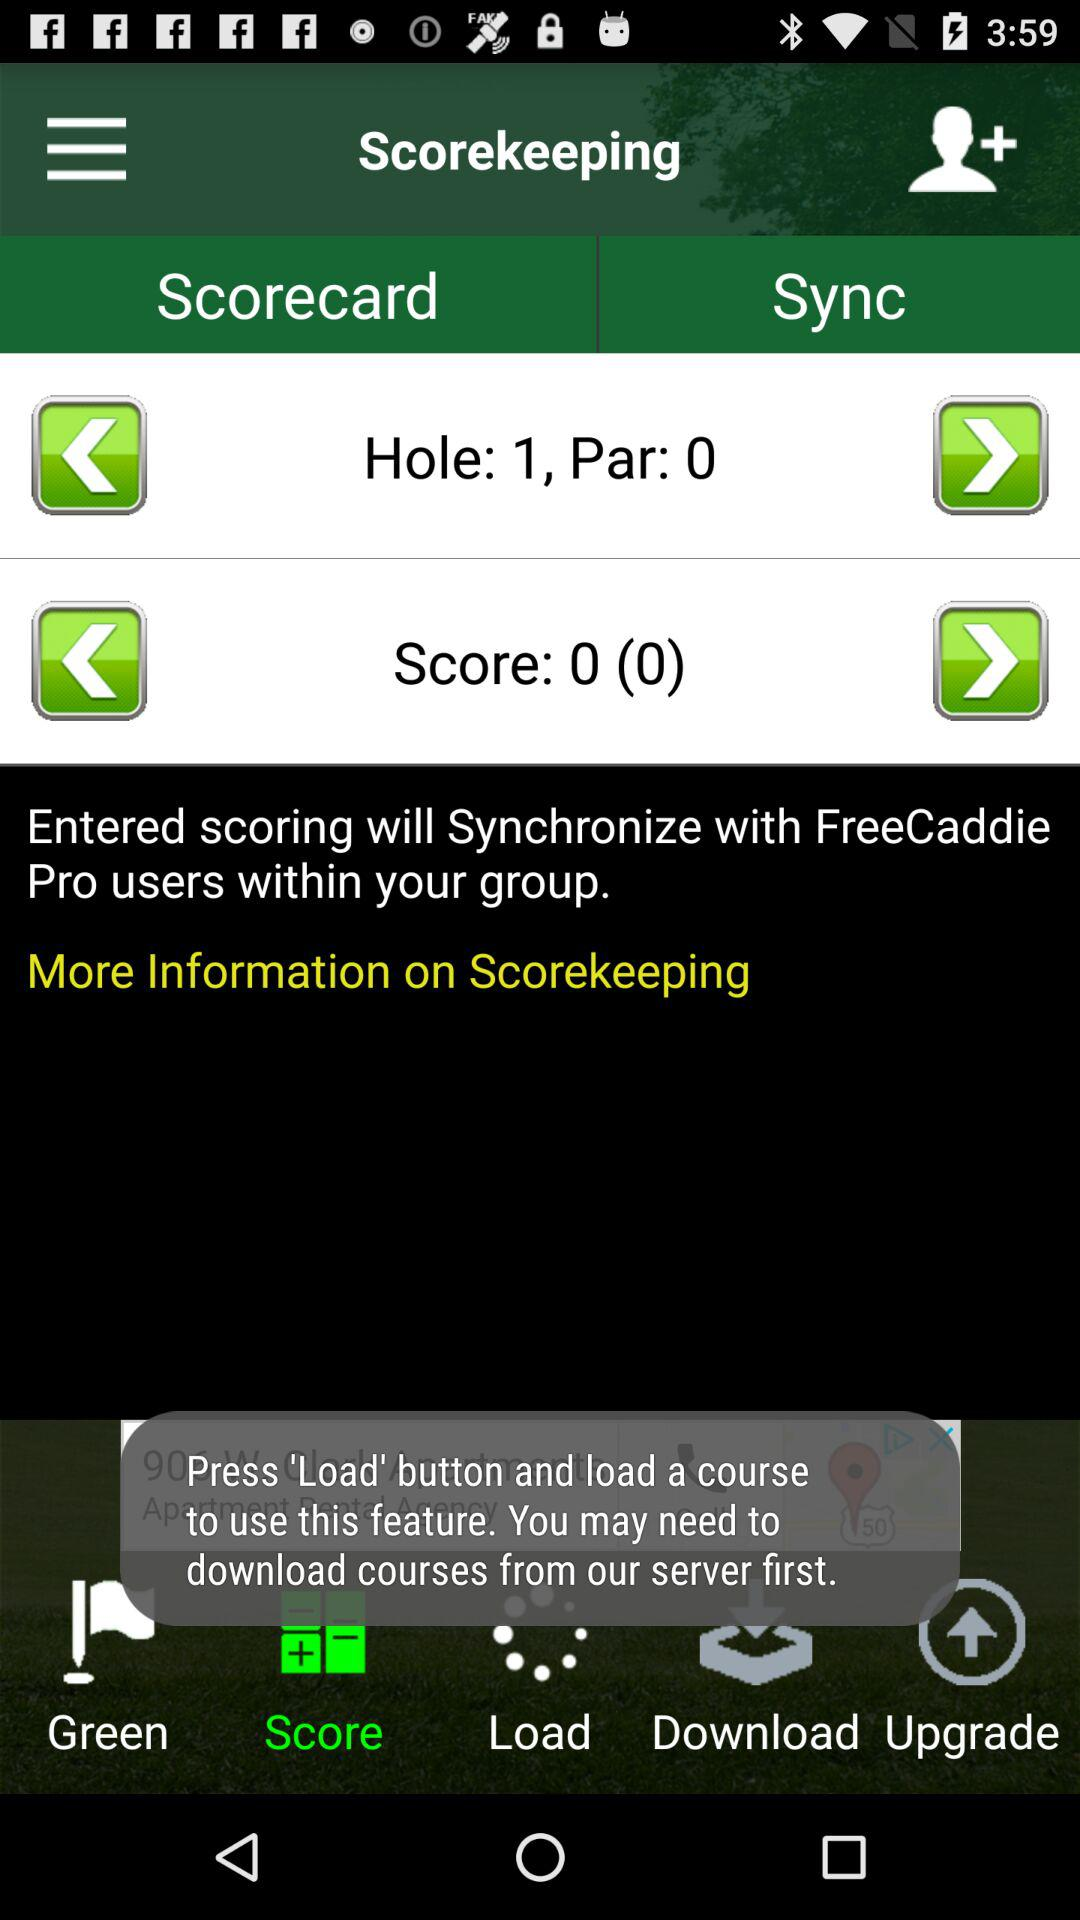What is the score? The score is 0 (0). 